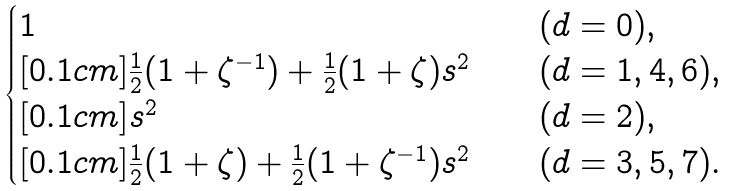Convert formula to latex. <formula><loc_0><loc_0><loc_500><loc_500>\begin{cases} 1 \quad & ( d = 0 ) , \\ [ 0 . 1 c m ] \frac { 1 } { 2 } ( 1 + \zeta ^ { - 1 } ) + \frac { 1 } { 2 } ( 1 + \zeta ) s ^ { 2 } \quad & ( d = 1 , 4 , 6 ) , \\ [ 0 . 1 c m ] s ^ { 2 } \quad & ( d = 2 ) , \\ [ 0 . 1 c m ] \frac { 1 } { 2 } ( 1 + \zeta ) + \frac { 1 } { 2 } ( 1 + \zeta ^ { - 1 } ) s ^ { 2 } \quad & ( d = 3 , 5 , 7 ) . \end{cases}</formula> 